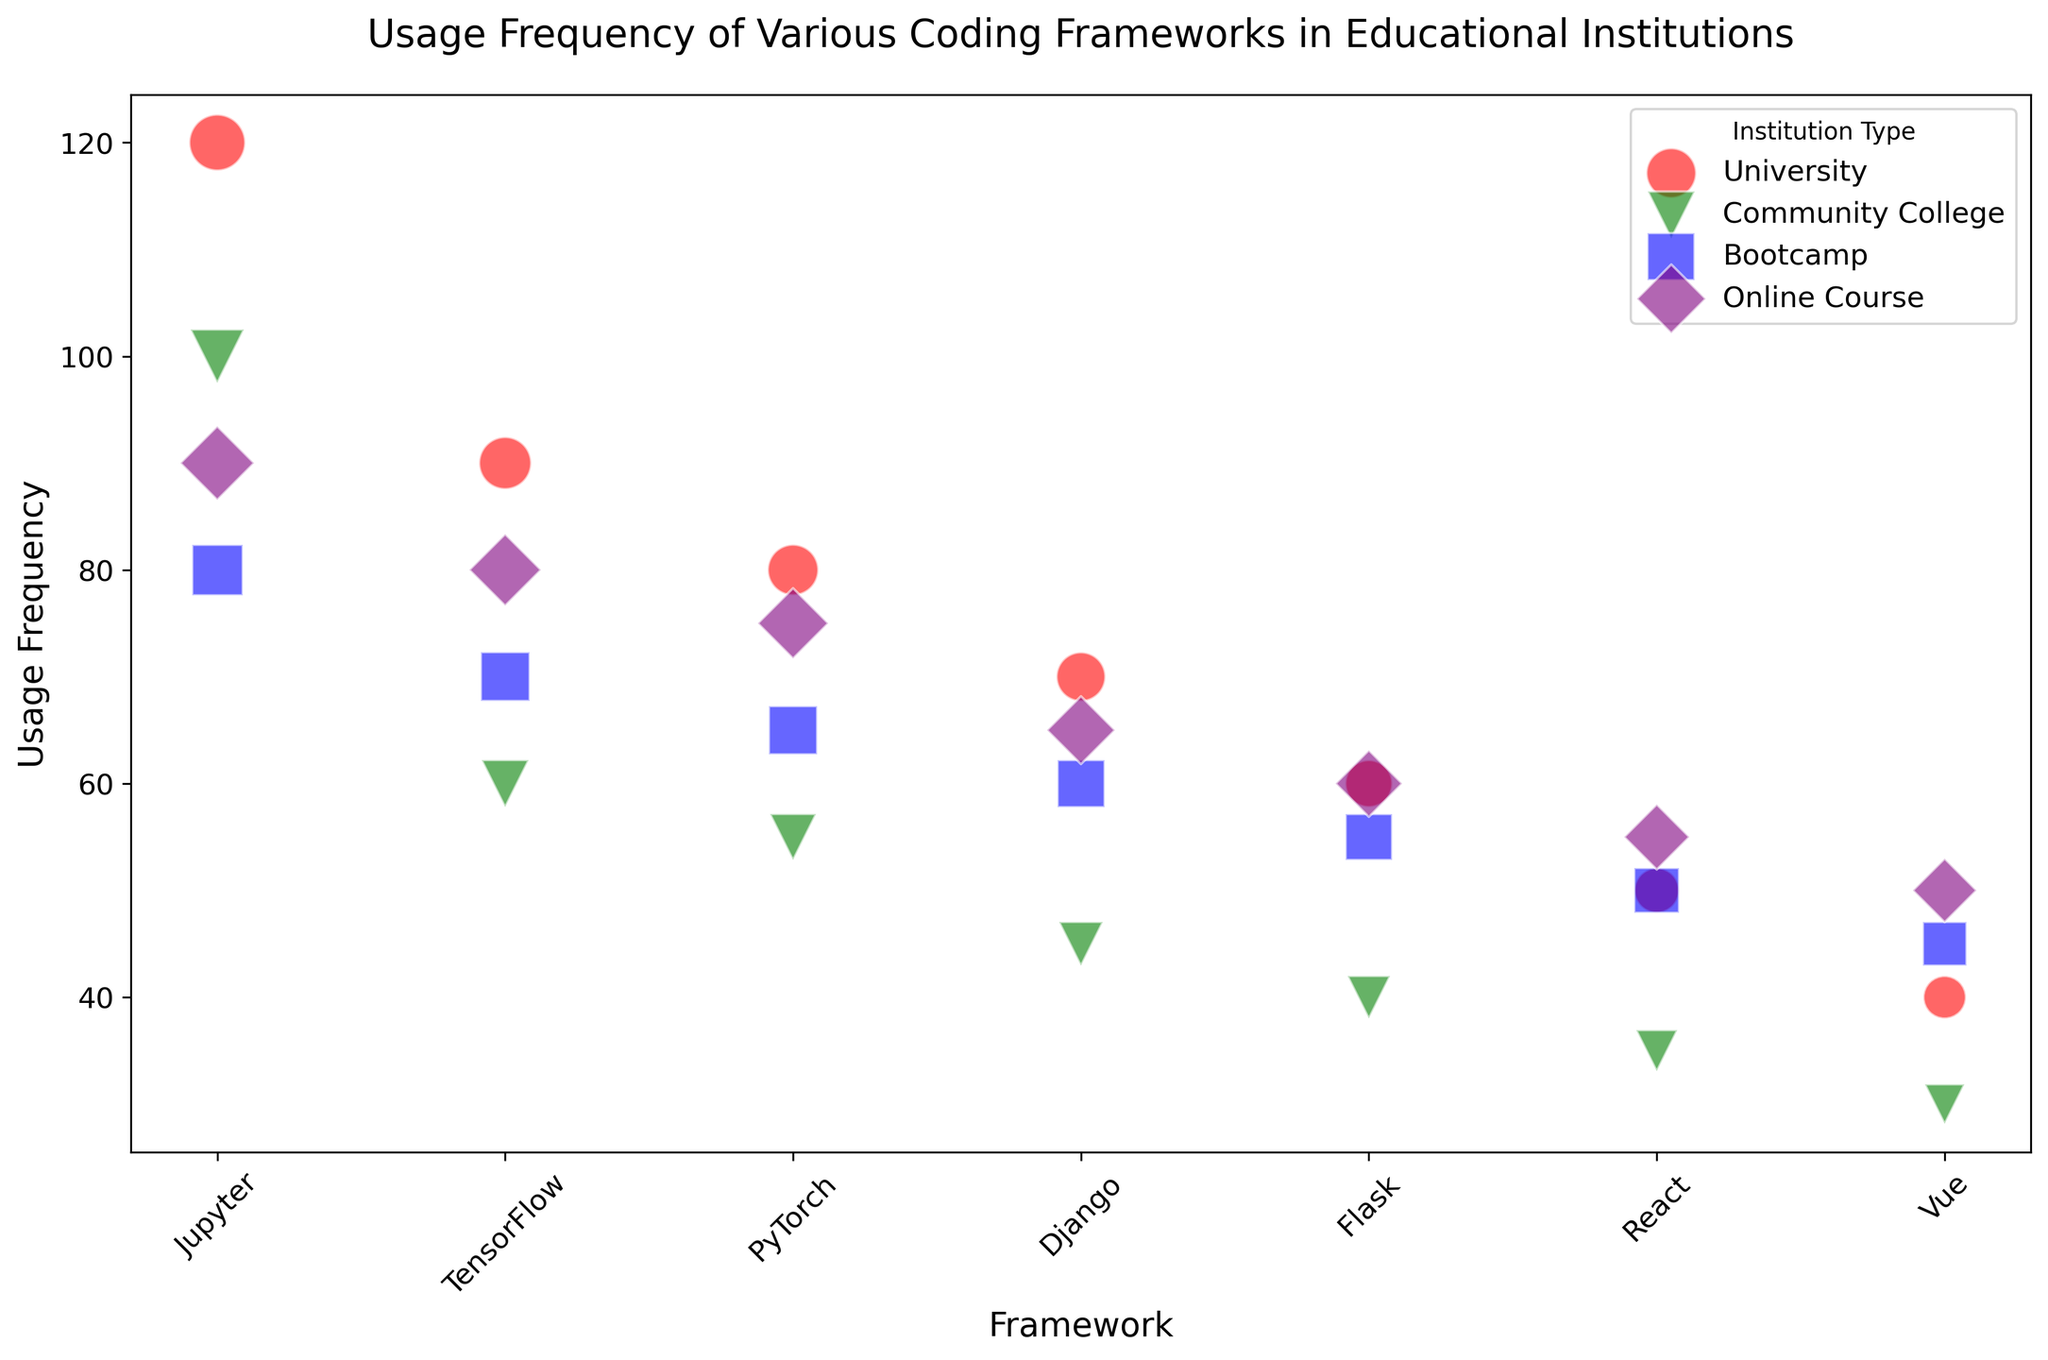Which institution type uses Jupyter the most? The bubble size representing the usage of Jupyter is largest for Universities.
Answer: University Which framework has the highest usage frequency in Bootcamps? The bubble size indicating the usage in Bootcamps is largest for Jupyter.
Answer: Jupyter Is the usage frequency of TensorFlow higher in Universities or Community Colleges? The bubble for TensorFlow is larger in Universities compared to Community Colleges.
Answer: Universities What is the difference in the usage frequency of PyTorch between Online Courses and Community Colleges? The bubble sizes for PyTorch indicate a usage of 75 for Online Courses and 55 for Community Colleges. The difference is 75 - 55.
Answer: 20 Which institution type has the smallest bubble for Vue? The smallest bubble for Vue is found in Community Colleges.
Answer: Community College How many institution types show a usage frequency of 60 for Flask? By inspecting the bubbles, Universities, Community Colleges, and Online Courses each have one Flask bubble with a frequency of 60.
Answer: 3 Which institution type has more framework usage consistency in terms of bubble sizes? By observing the bubble sizes, Bootcamps have closely sized bubbles for different frameworks, indicating a more consistent usage across frameworks compared to other institution types.
Answer: Bootcamp By how much does the usage frequency of Django in Universities exceed that in Bootcamps? The bubble size indicates Django's frequency is 70 for Universities and 60 for Bootcamps. The exceeding amount is 70 - 60.
Answer: 10 What color is used to represent Online Courses? The legend shows that Online Courses are represented by the color purple.
Answer: Purple 